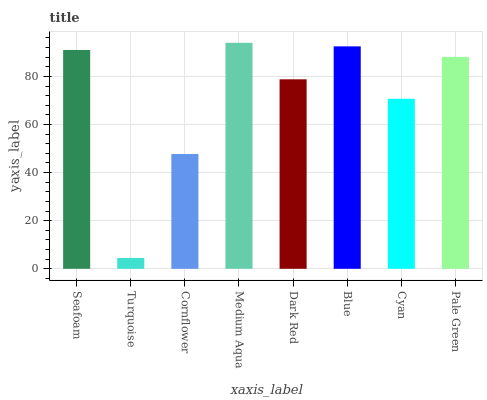Is Turquoise the minimum?
Answer yes or no. Yes. Is Medium Aqua the maximum?
Answer yes or no. Yes. Is Cornflower the minimum?
Answer yes or no. No. Is Cornflower the maximum?
Answer yes or no. No. Is Cornflower greater than Turquoise?
Answer yes or no. Yes. Is Turquoise less than Cornflower?
Answer yes or no. Yes. Is Turquoise greater than Cornflower?
Answer yes or no. No. Is Cornflower less than Turquoise?
Answer yes or no. No. Is Pale Green the high median?
Answer yes or no. Yes. Is Dark Red the low median?
Answer yes or no. Yes. Is Cyan the high median?
Answer yes or no. No. Is Cornflower the low median?
Answer yes or no. No. 